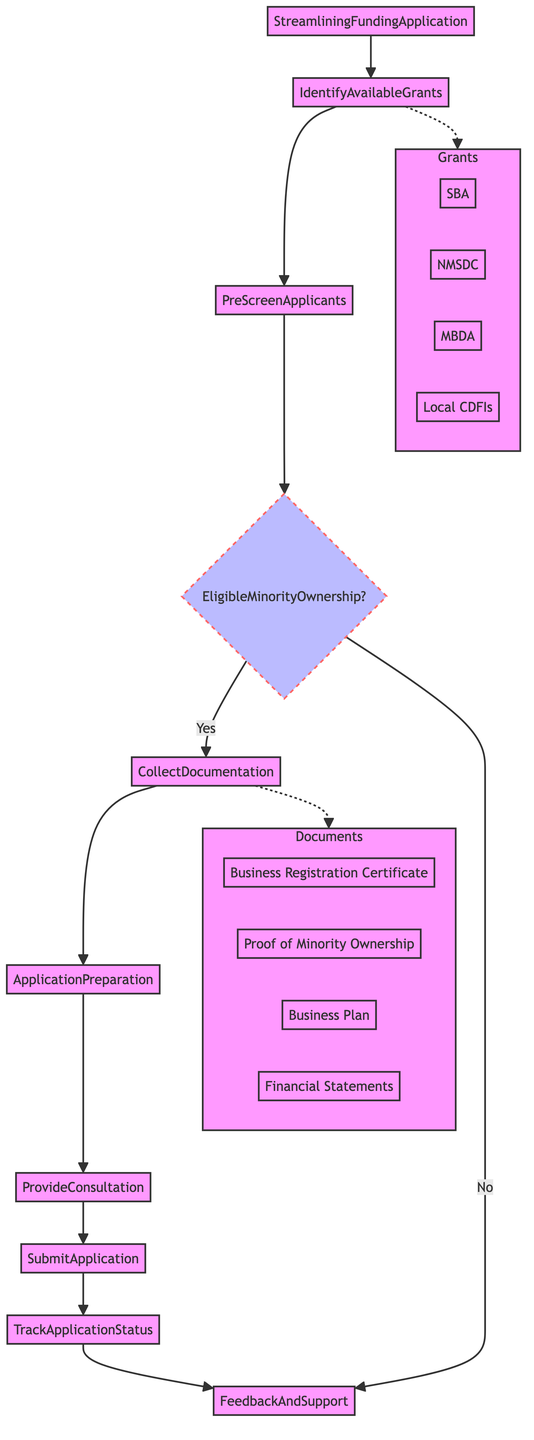What is the first step in the diagram? The diagram starts at the "StreamliningFundingApplication" which leads to the first step, "IdentifyAvailableGrants." This establishes the initial action in the process of streamlining funding applications.
Answer: IdentifyAvailableGrants How many documents are listed in the diagram? The diagram includes four documents listed in the "Documents" subgraph: Business Registration Certificate, Proof of Minority Ownership, Business Plan, and Financial Statements. By counting these items, we find there are four total.
Answer: 4 What condition must be met for a business to proceed after the PreScreenApplicants step? The condition is labeled "EligibleMinorityOwnership" which states that the business must be at least 51% owned by minority individuals. This is a critical eligibility requirement for moving forward in the application process.
Answer: EligibleMinorityOwnership What happens if a business does not meet the eligibility condition? If the business does not meet the eligibility condition of minority ownership, the flowchart directs to the "FeedbackAndSupport" step, indicating that the application process cannot continue in a standard manner, and support will be provided.
Answer: FeedbackAndSupport Which entities are related to funding opportunities in the diagram? The diagram identifies four funding entities: Small Business Administration (SBA), National Minority Supplier Development Council (NMSDC), Minority Business Development Agency (MBDA), and Local Community Development Financial Institutions (CDFIs), showcasing the options available for minority-owned businesses.
Answer: SBA, NMSDC, MBDA, Local CDFIs What documentation is collected immediately after screening applicants? After completing the PreScreenApplicants step, the next step directs to "CollectDocumentation," which includes gathering necessary documents to verify eligibility and preparedness for the funding application process.
Answer: CollectDocumentation How are applicants assisted during the application preparation stage? During the "ApplicationPreparation" step, the process involves assisting applicants in filling out grant application forms, ensuring attention to detail and accuracy. This indicates a supportive approach in preparing vital information for the funding requests.
Answer: ApplicationPreparation What is monitored after the application is submitted? After submission in the "SubmitApplication" step, the next phase involves monitoring and periodically communicating the "TrackApplicationStatus" to ensure the applicant is updated on their funding request's progress, which is essential for applicant engagement.
Answer: TrackApplicationStatus 